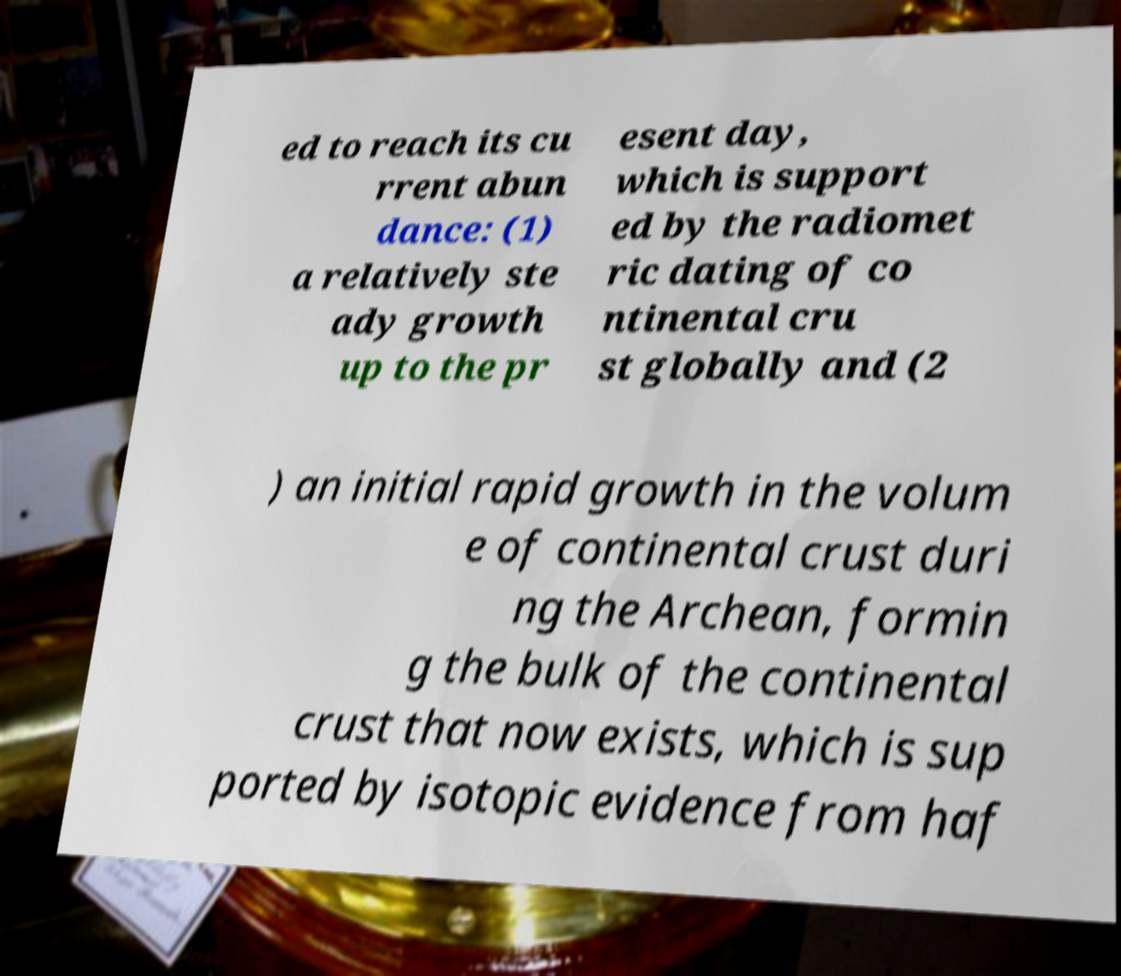What messages or text are displayed in this image? I need them in a readable, typed format. ed to reach its cu rrent abun dance: (1) a relatively ste ady growth up to the pr esent day, which is support ed by the radiomet ric dating of co ntinental cru st globally and (2 ) an initial rapid growth in the volum e of continental crust duri ng the Archean, formin g the bulk of the continental crust that now exists, which is sup ported by isotopic evidence from haf 